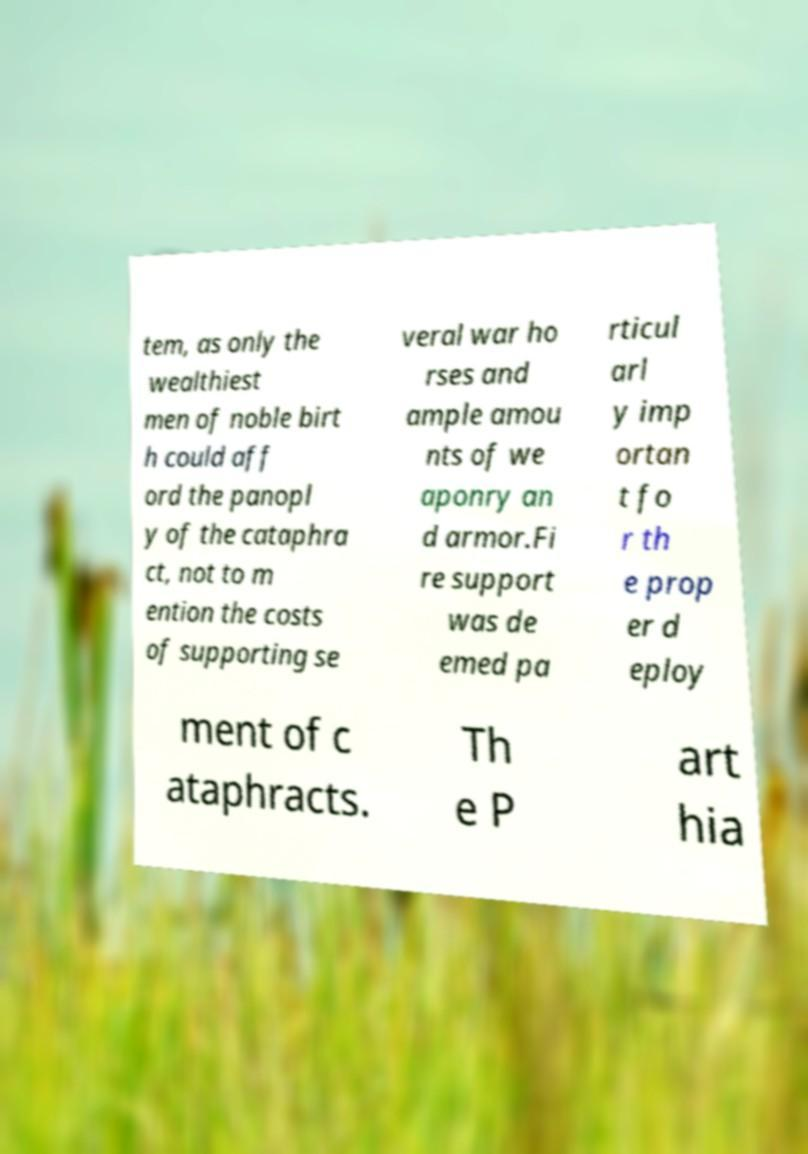Please read and relay the text visible in this image. What does it say? tem, as only the wealthiest men of noble birt h could aff ord the panopl y of the cataphra ct, not to m ention the costs of supporting se veral war ho rses and ample amou nts of we aponry an d armor.Fi re support was de emed pa rticul arl y imp ortan t fo r th e prop er d eploy ment of c ataphracts. Th e P art hia 